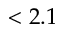<formula> <loc_0><loc_0><loc_500><loc_500>< 2 . 1</formula> 